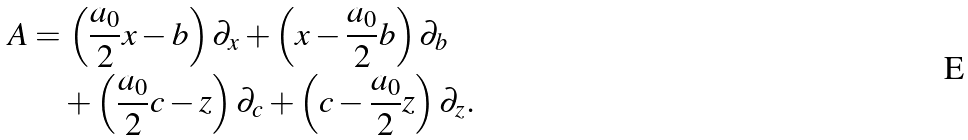Convert formula to latex. <formula><loc_0><loc_0><loc_500><loc_500>\ A & = \left ( \frac { a _ { 0 } } 2 x - b \right ) \partial _ { x } + \left ( x - \frac { a _ { 0 } } 2 b \right ) \partial _ { b } \\ & \quad + \left ( \frac { a _ { 0 } } 2 c - z \right ) \partial _ { c } + \left ( c - \frac { a _ { 0 } } 2 z \right ) \partial _ { z } .</formula> 